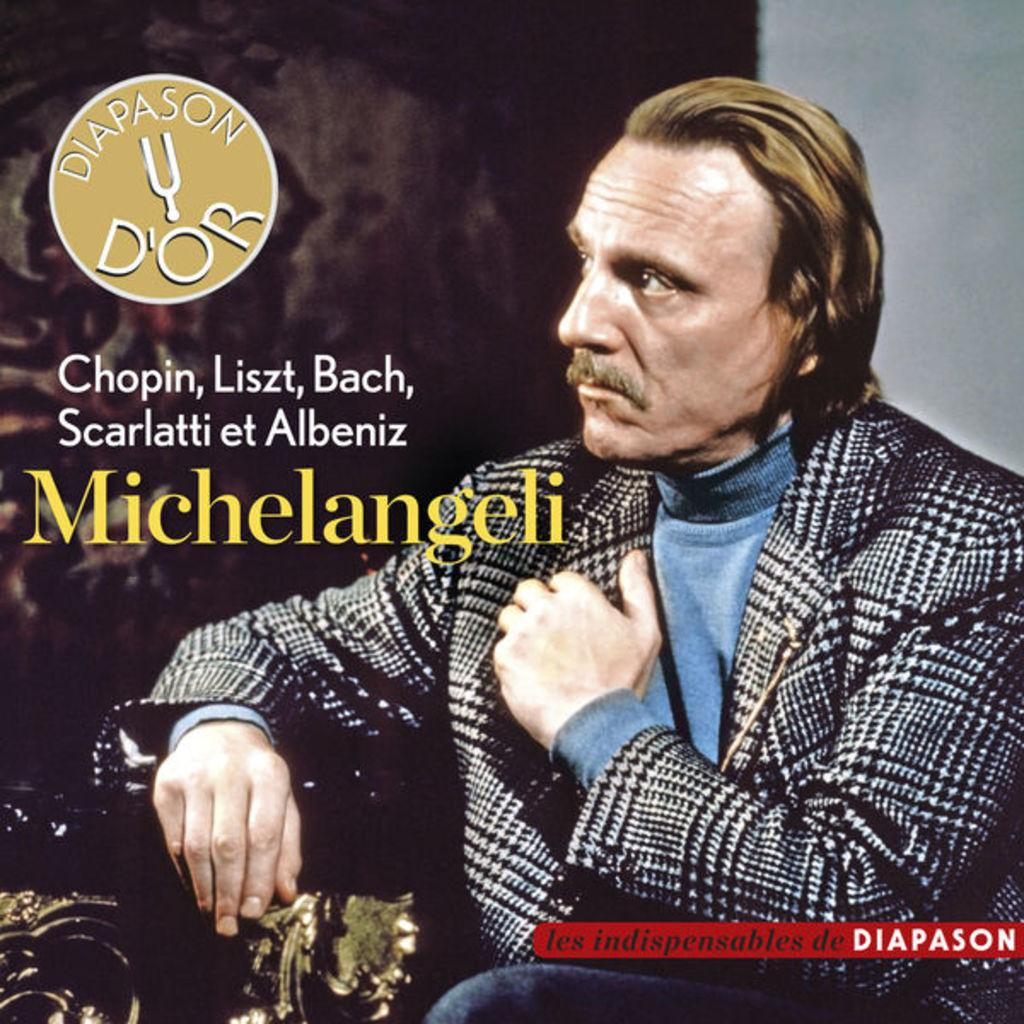What is featured in the image? There is a poster and a person sitting on a chair in the image. Can you describe the background of the image? There is a wall in the background of the image. Is there any text visible in the image? Yes, there is some text on the left side of the image. What type of nail is being hammered into the person's stomach in the image? There is no nail or person with a stomach issue present in the image. 